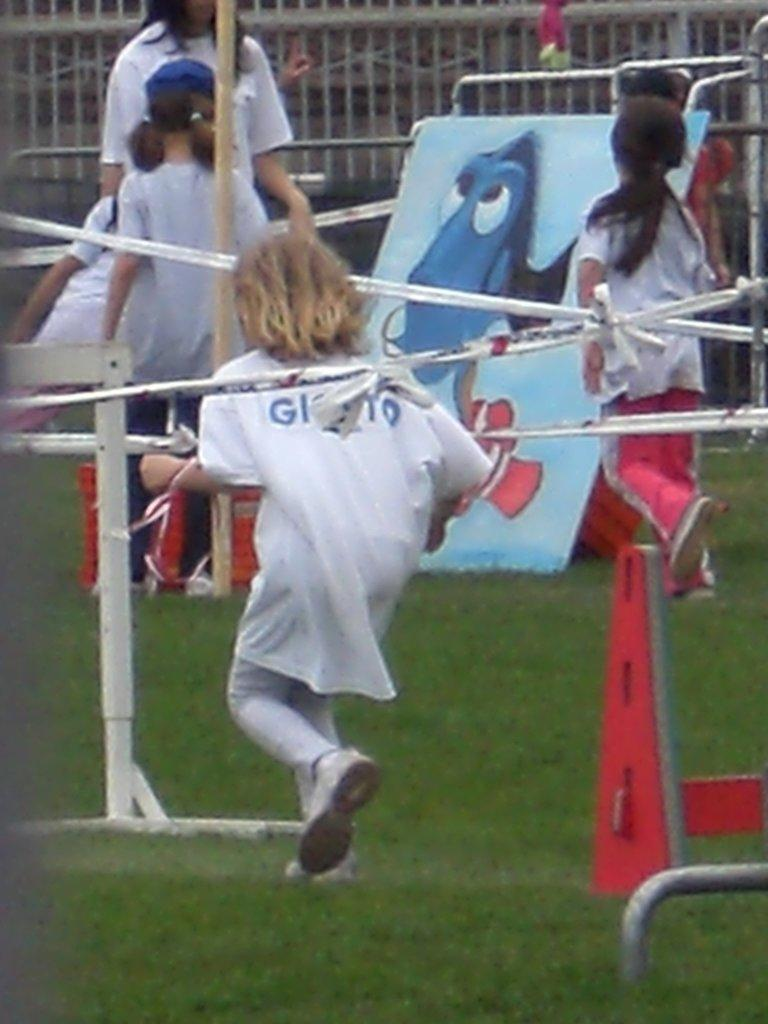What is the main subject of the image? The main subject of the image is the girls in the center of the image. What objects can be seen in the image besides the girls? There are poles in the image. What can be seen in the background of the image? There is a fencing in the background of the image. What type of ground is visible at the bottom of the image? There is grass at the bottom of the image. What type of apparel is the grass wearing in the image? The grass is not wearing any apparel, as it is a natural ground cover. How does the fencing stretch across the image? The fencing does not stretch in the image; it is a stationary object in the background. 